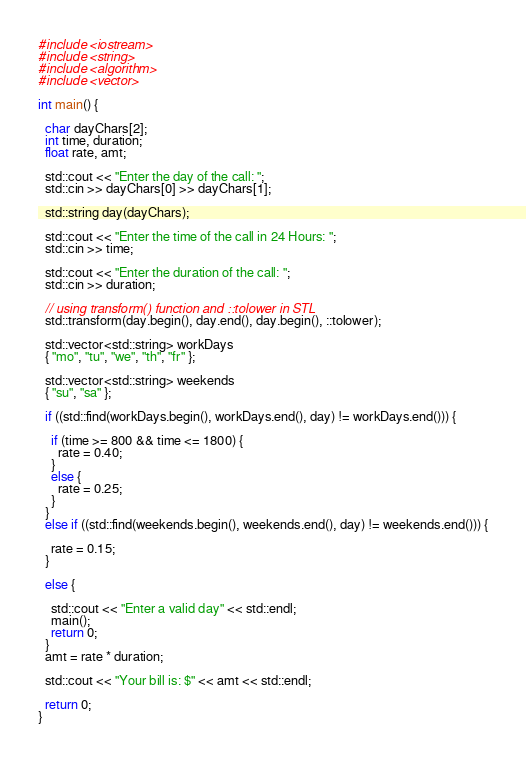Convert code to text. <code><loc_0><loc_0><loc_500><loc_500><_C++_>#include <iostream>
#include <string>
#include <algorithm>
#include <vector>

int main() {

  char dayChars[2];
  int time, duration;
  float rate, amt;
  
  std::cout << "Enter the day of the call: ";
  std::cin >> dayChars[0] >> dayChars[1];
  
  std::string day(dayChars);
  
  std::cout << "Enter the time of the call in 24 Hours: ";
  std::cin >> time;

  std::cout << "Enter the duration of the call: ";
  std::cin >> duration;

  // using transform() function and ::tolower in STL
  std::transform(day.begin(), day.end(), day.begin(), ::tolower);
  
  std::vector<std::string> workDays
  { "mo", "tu", "we", "th", "fr" };

  std::vector<std::string> weekends
  { "su", "sa" };
  
  if ((std::find(workDays.begin(), workDays.end(), day) != workDays.end())) {

    if (time >= 800 && time <= 1800) {
      rate = 0.40;
    }
    else {
      rate = 0.25;
    }
  }
  else if ((std::find(weekends.begin(), weekends.end(), day) != weekends.end())) {

    rate = 0.15;
  }

  else {

    std::cout << "Enter a valid day" << std::endl;
    main();
    return 0;
  }
  amt = rate * duration;

  std::cout << "Your bill is: $" << amt << std::endl;
  
  return 0;
}
</code> 